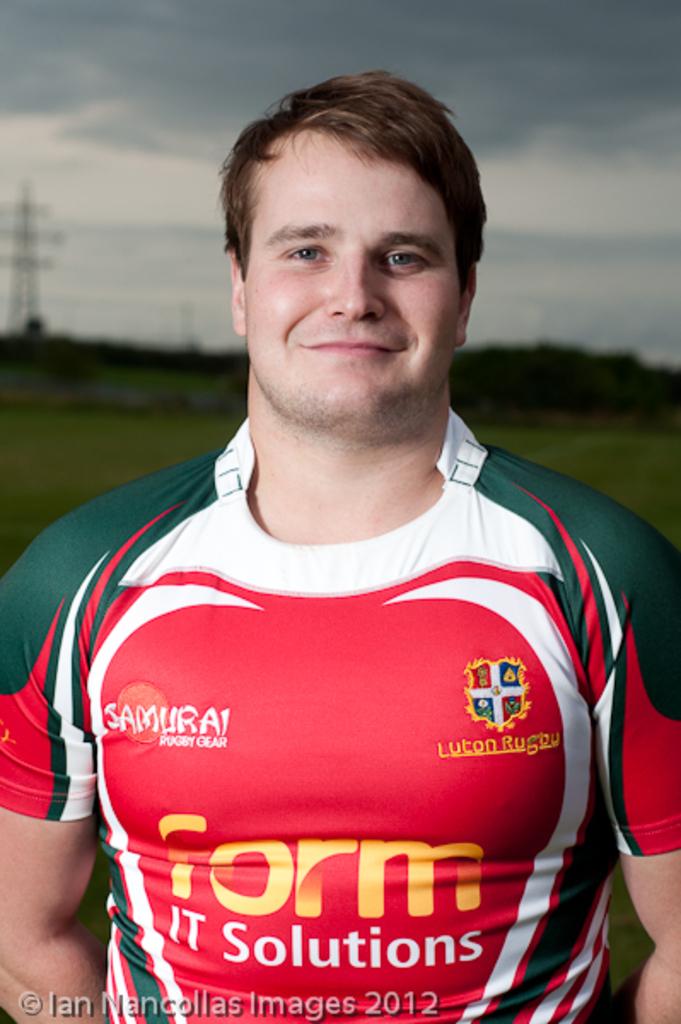Is samurai one of his sponsors?
Your response must be concise. Yes. 